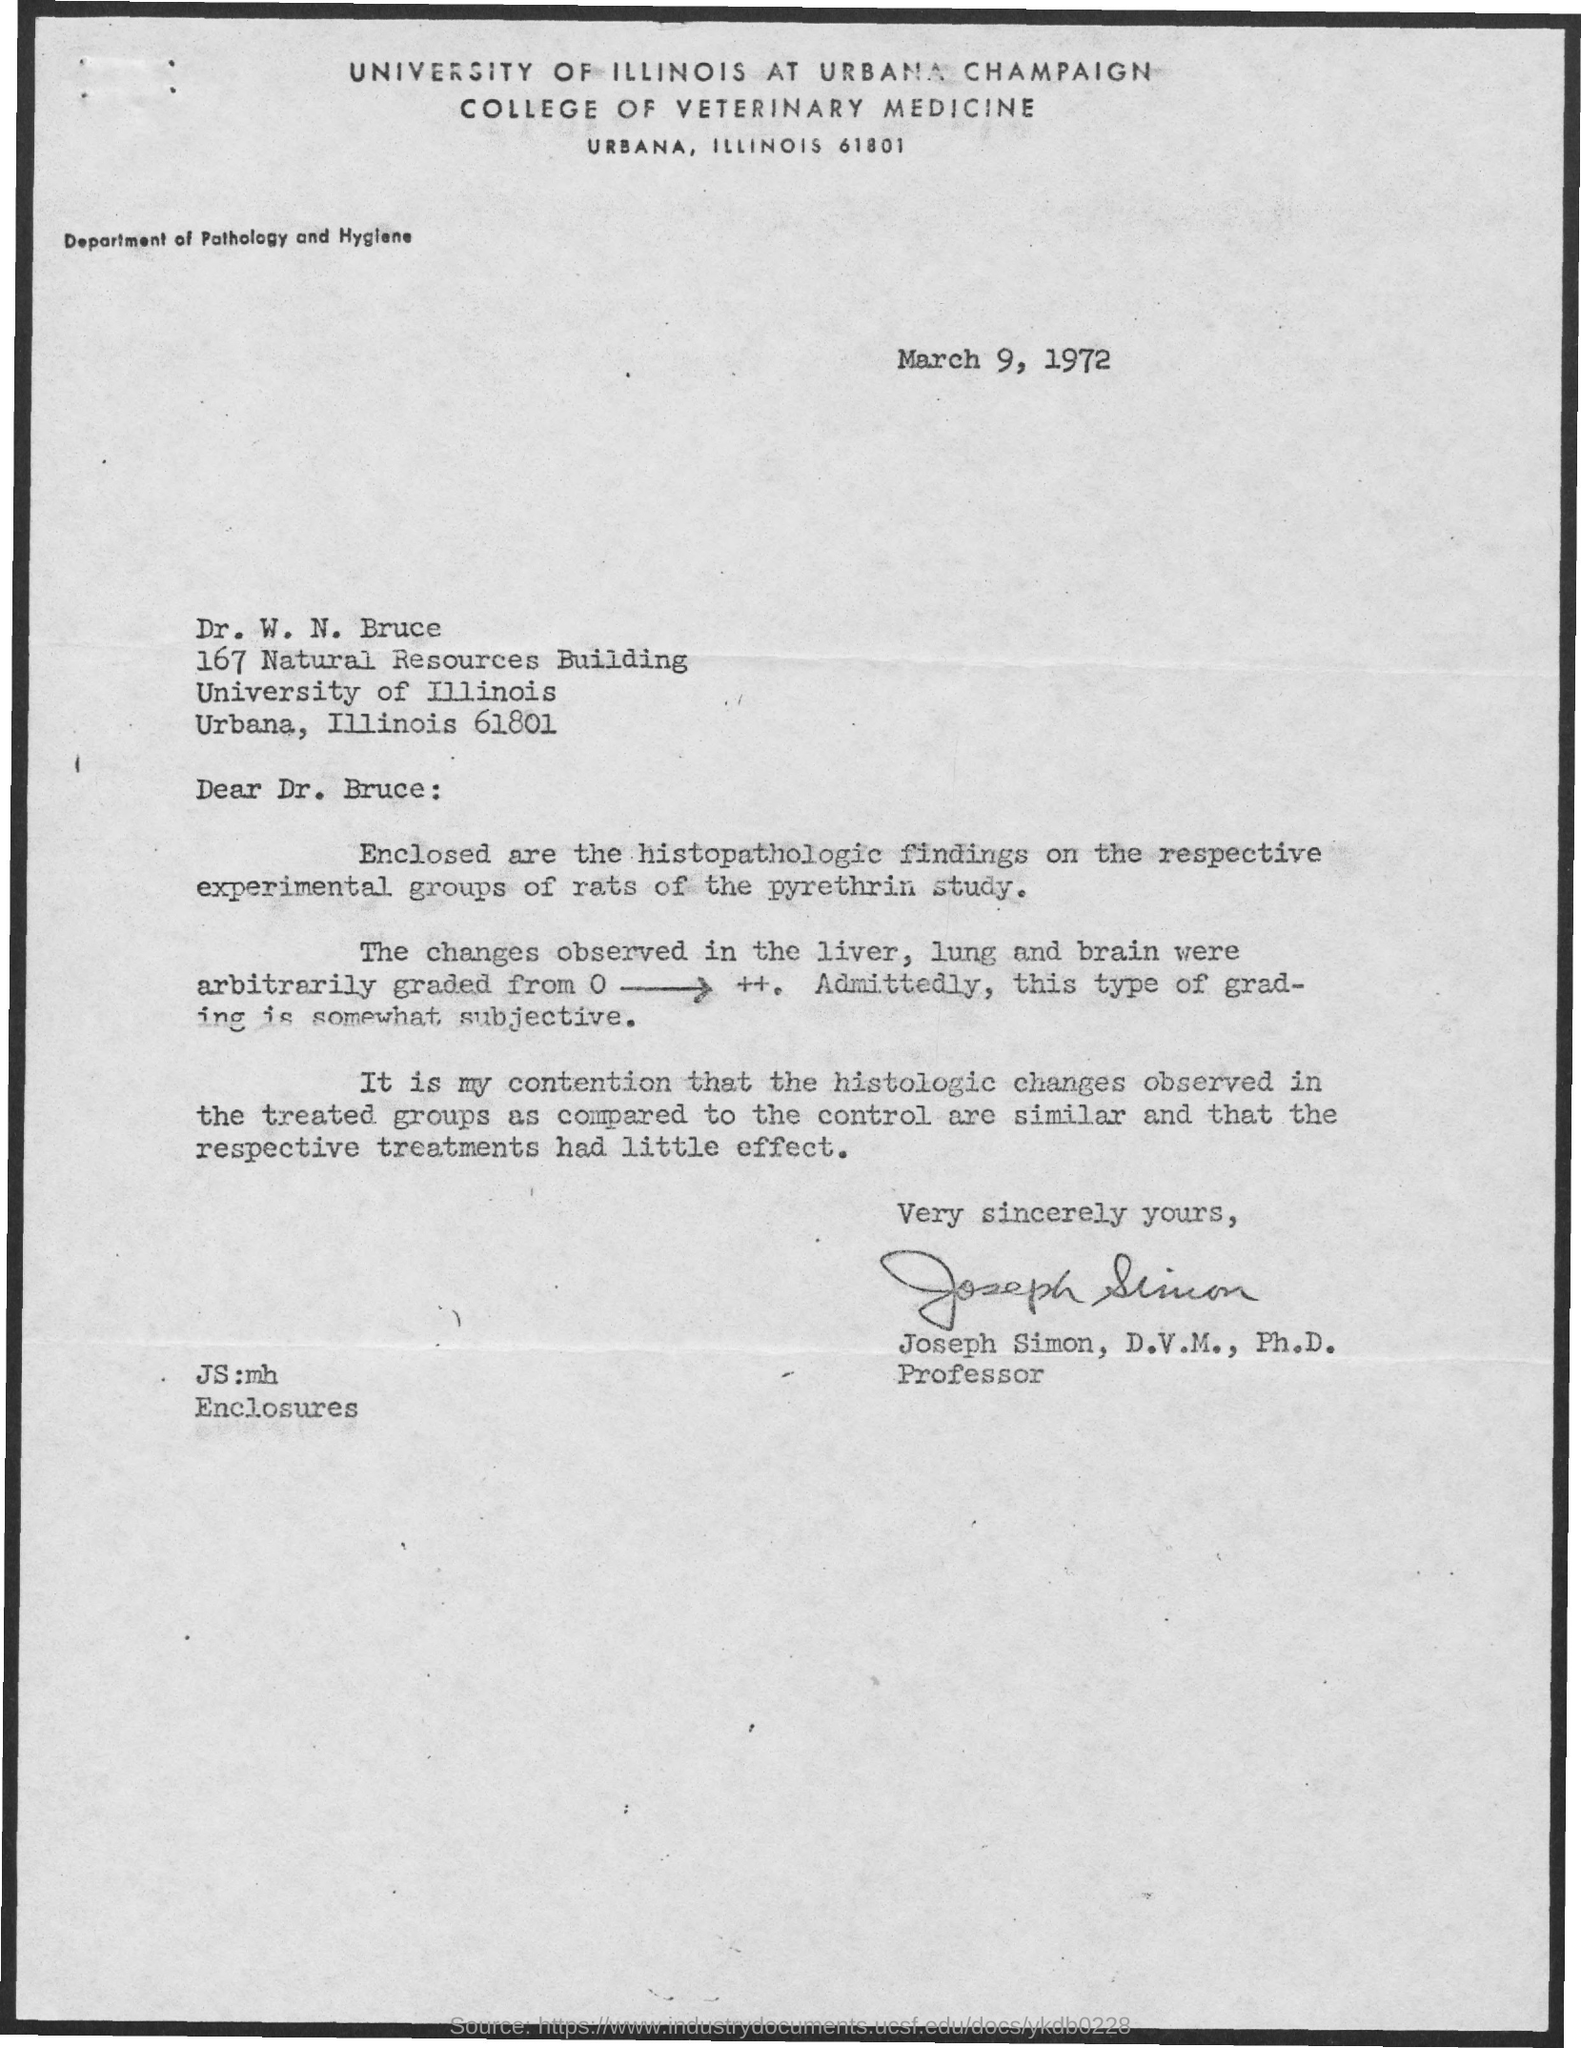Identify some key points in this picture. The enclosures include histopathologic findings. Changes in liver, lung, and brain tissues have been observed. The letter is addressed to Dr. W. N. Bruce. The study used pyrethrin as the chemical. The laboratory animal used for the study is rats. 